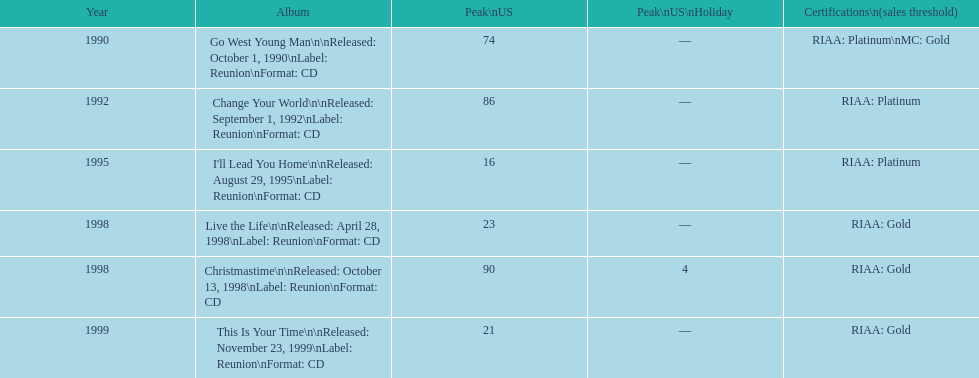How many tracks are listed from 1998? 2. 